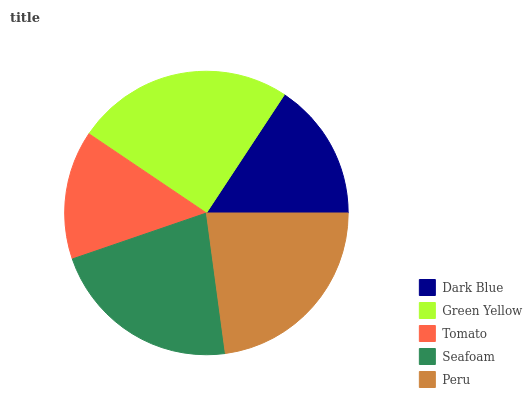Is Tomato the minimum?
Answer yes or no. Yes. Is Green Yellow the maximum?
Answer yes or no. Yes. Is Green Yellow the minimum?
Answer yes or no. No. Is Tomato the maximum?
Answer yes or no. No. Is Green Yellow greater than Tomato?
Answer yes or no. Yes. Is Tomato less than Green Yellow?
Answer yes or no. Yes. Is Tomato greater than Green Yellow?
Answer yes or no. No. Is Green Yellow less than Tomato?
Answer yes or no. No. Is Seafoam the high median?
Answer yes or no. Yes. Is Seafoam the low median?
Answer yes or no. Yes. Is Dark Blue the high median?
Answer yes or no. No. Is Tomato the low median?
Answer yes or no. No. 